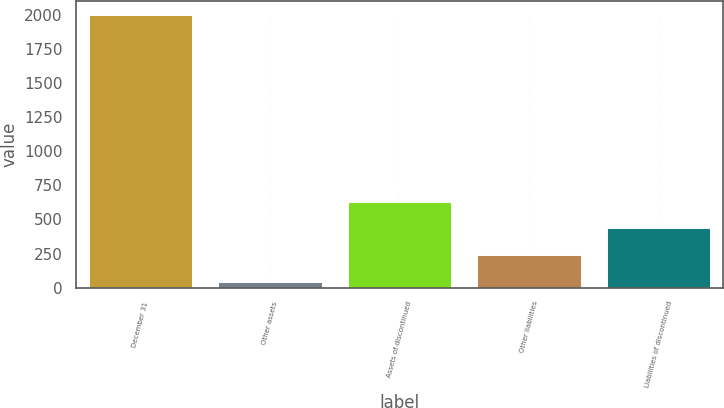<chart> <loc_0><loc_0><loc_500><loc_500><bar_chart><fcel>December 31<fcel>Other assets<fcel>Assets of discontinued<fcel>Other liabilities<fcel>Liabilities of discontinued<nl><fcel>2004<fcel>43<fcel>631.3<fcel>239.1<fcel>435.2<nl></chart> 